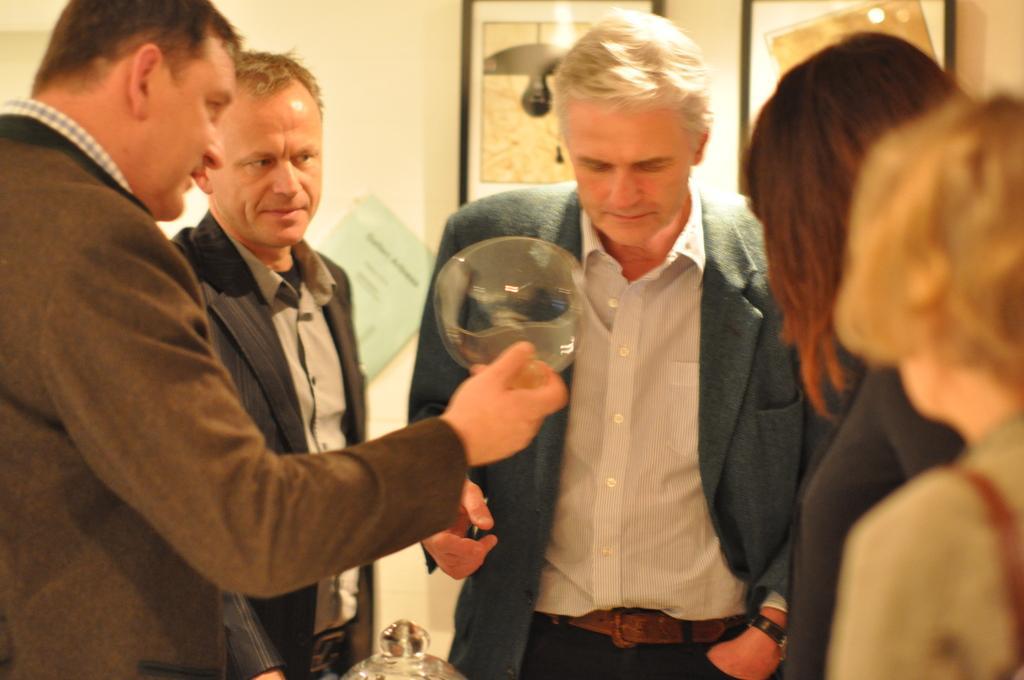Describe this image in one or two sentences. In this image I can see few people standing and wearing different color dresses. One person is holding something. Back I can see few frames and wall. 